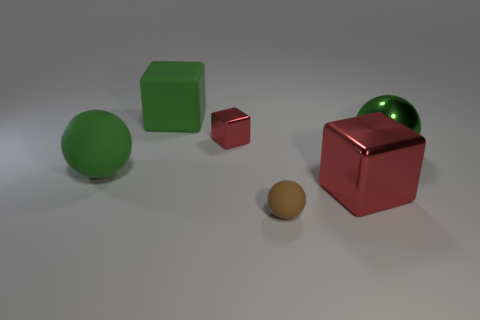Add 2 big spheres. How many objects exist? 8 Subtract all big red blocks. Subtract all matte things. How many objects are left? 2 Add 4 matte spheres. How many matte spheres are left? 6 Add 2 green rubber spheres. How many green rubber spheres exist? 3 Subtract 0 blue cylinders. How many objects are left? 6 